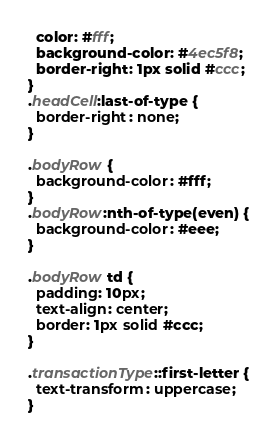<code> <loc_0><loc_0><loc_500><loc_500><_CSS_>  color: #fff;
  background-color: #4ec5f8;
  border-right: 1px solid #ccc;
}
.headCell:last-of-type {
  border-right: none;
}

.bodyRow {
  background-color: #fff;
}
.bodyRow:nth-of-type(even) {
  background-color: #eee;
}

.bodyRow td {
  padding: 10px;
  text-align: center;
  border: 1px solid #ccc;
}

.transactionType::first-letter {
  text-transform: uppercase;
}
</code> 